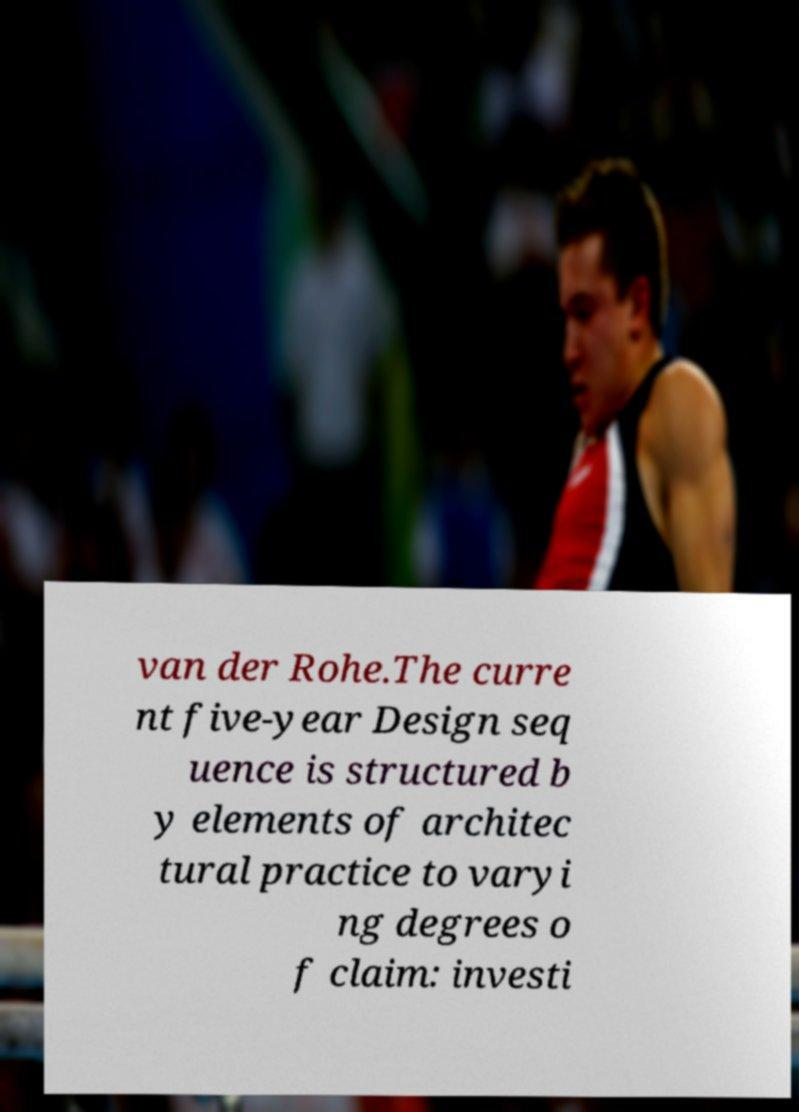Please identify and transcribe the text found in this image. van der Rohe.The curre nt five-year Design seq uence is structured b y elements of architec tural practice to varyi ng degrees o f claim: investi 